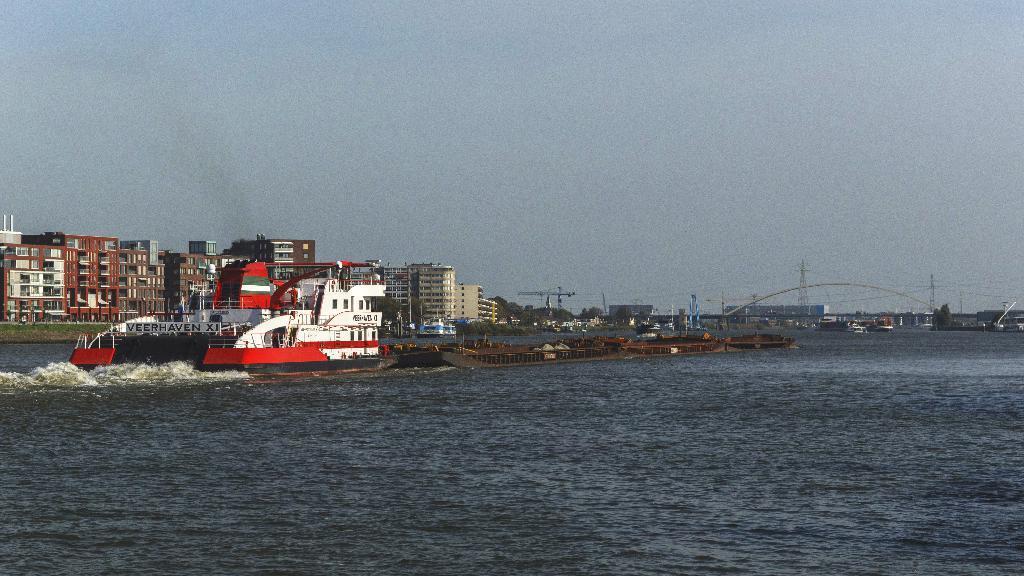Describe this image in one or two sentences. In this picture we can see a few ships in the water. Waves are seen in water. There are some buildings, wires and towers in the background. 